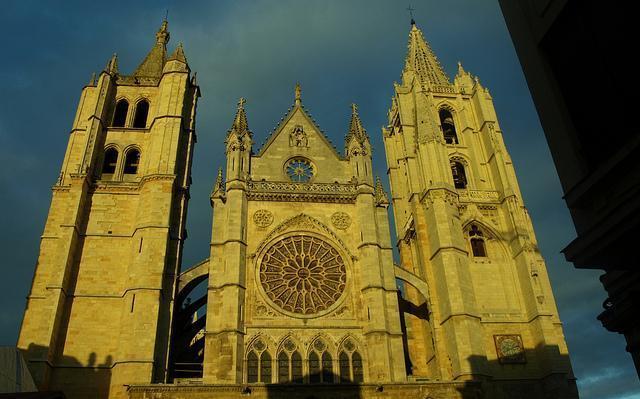How many buses  are in the photo?
Give a very brief answer. 0. 